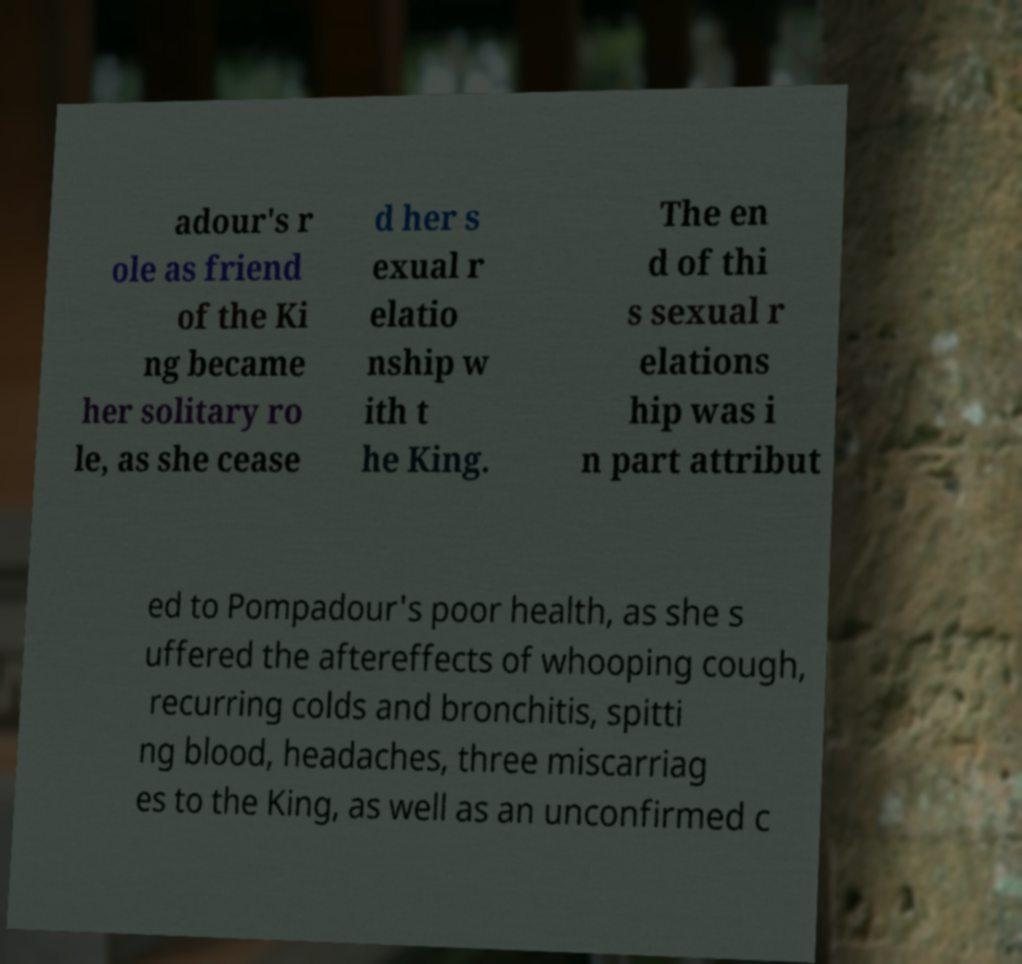Can you accurately transcribe the text from the provided image for me? adour's r ole as friend of the Ki ng became her solitary ro le, as she cease d her s exual r elatio nship w ith t he King. The en d of thi s sexual r elations hip was i n part attribut ed to Pompadour's poor health, as she s uffered the aftereffects of whooping cough, recurring colds and bronchitis, spitti ng blood, headaches, three miscarriag es to the King, as well as an unconfirmed c 